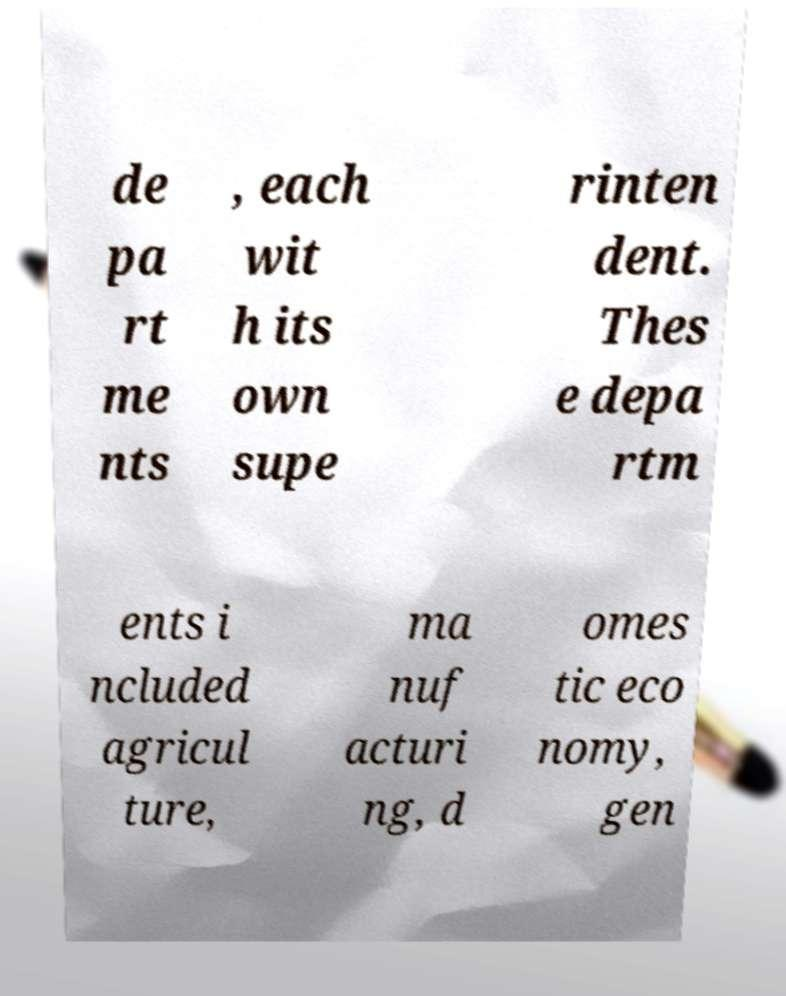Could you assist in decoding the text presented in this image and type it out clearly? de pa rt me nts , each wit h its own supe rinten dent. Thes e depa rtm ents i ncluded agricul ture, ma nuf acturi ng, d omes tic eco nomy, gen 